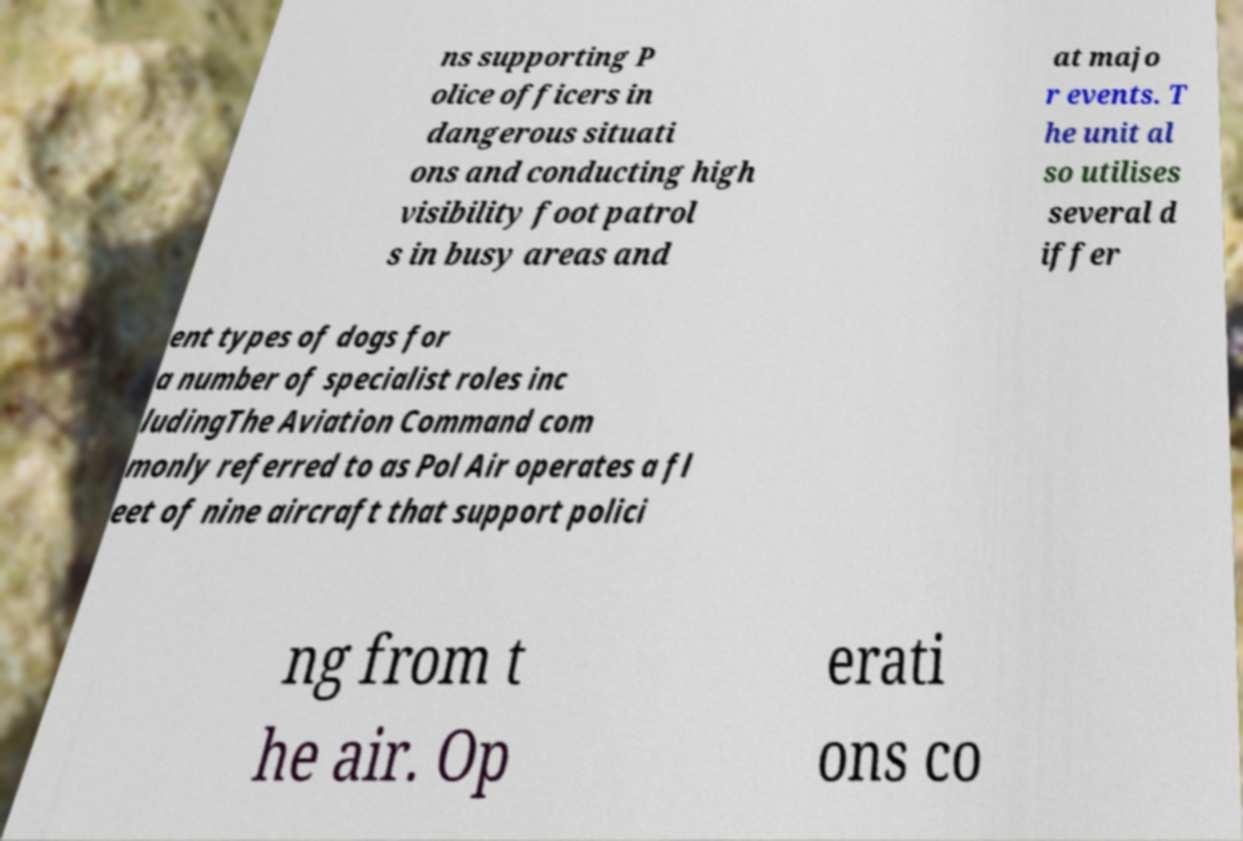Could you assist in decoding the text presented in this image and type it out clearly? ns supporting P olice officers in dangerous situati ons and conducting high visibility foot patrol s in busy areas and at majo r events. T he unit al so utilises several d iffer ent types of dogs for a number of specialist roles inc ludingThe Aviation Command com monly referred to as Pol Air operates a fl eet of nine aircraft that support polici ng from t he air. Op erati ons co 